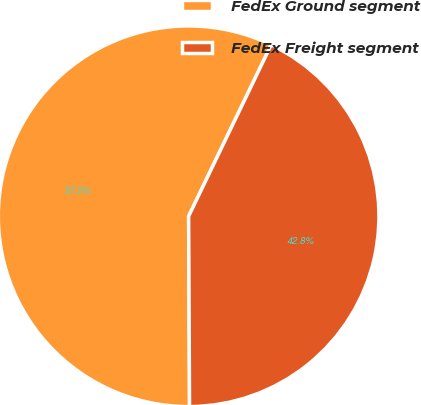Convert chart to OTSL. <chart><loc_0><loc_0><loc_500><loc_500><pie_chart><fcel>FedEx Ground segment<fcel>FedEx Freight segment<nl><fcel>57.22%<fcel>42.78%<nl></chart> 